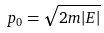<formula> <loc_0><loc_0><loc_500><loc_500>p _ { 0 } = \sqrt { 2 m | E | }</formula> 